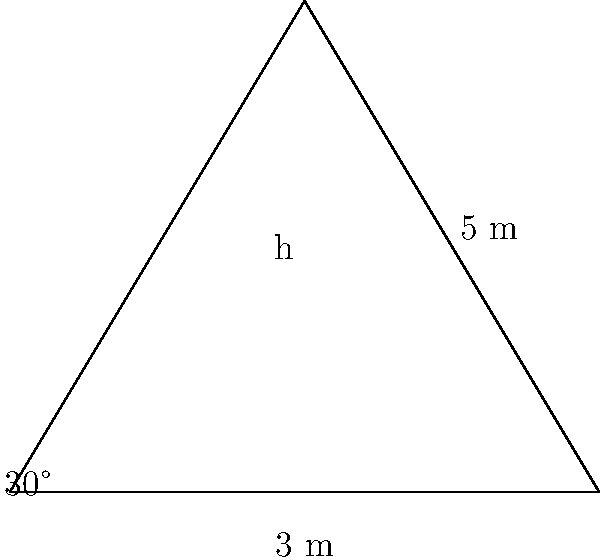As a wine critic specializing in cocktails, you've been asked to review a champagne tower at a high-end event. The tower is in the shape of a triangle, with a base width of 6 meters and a height that needs to be determined. You notice that the angle between the base and one side of the tower is 30°, and the slant height (the length of the side of the triangle) is 5 meters. Using trigonometric ratios, calculate the height of the champagne tower to the nearest centimeter. Let's approach this step-by-step:

1) First, we need to identify the trigonometric ratios we can use. We have a right-angled triangle where:
   - The hypotenuse (slant height) is 5 meters
   - The angle at the base is 30°
   - We need to find the opposite side (height)

2) The trigonometric ratio that relates the opposite side to the hypotenuse is sine:

   $$\sin \theta = \frac{\text{opposite}}{\text{hypotenuse}}$$

3) In this case:

   $$\sin 30° = \frac{h}{5}$$

4) We know that $\sin 30° = \frac{1}{2}$, so we can substitute this:

   $$\frac{1}{2} = \frac{h}{5}$$

5) To solve for h, we multiply both sides by 5:

   $$h = 5 \times \frac{1}{2} = 2.5$$

6) Therefore, the height of the champagne tower is 2.5 meters.

7) Converting to centimeters:

   $$2.5 \text{ m} = 250 \text{ cm}$$

Thus, the height of the champagne tower is 250 cm.
Answer: 250 cm 